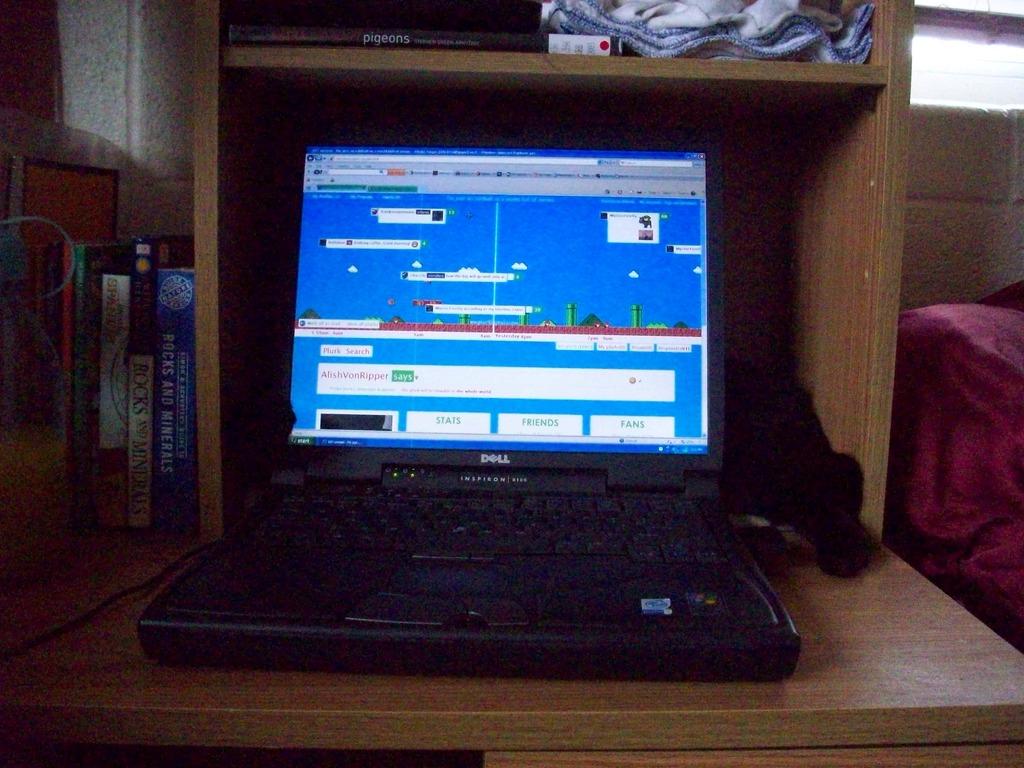What brand is the laptop?
Your answer should be very brief. Dell. What is the last word in the white boxes on the bottom of the screen?
Offer a very short reply. Fans. 